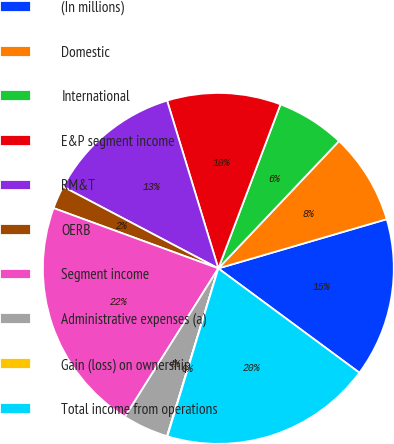Convert chart. <chart><loc_0><loc_0><loc_500><loc_500><pie_chart><fcel>(In millions)<fcel>Domestic<fcel>International<fcel>E&P segment income<fcel>RM&T<fcel>OERB<fcel>Segment income<fcel>Administrative expenses (a)<fcel>Gain (loss) on ownership<fcel>Total income from operations<nl><fcel>14.66%<fcel>8.4%<fcel>6.31%<fcel>10.48%<fcel>12.57%<fcel>2.13%<fcel>21.64%<fcel>4.22%<fcel>0.04%<fcel>19.55%<nl></chart> 